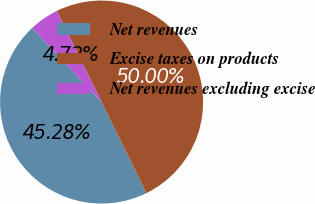<chart> <loc_0><loc_0><loc_500><loc_500><pie_chart><fcel>Net revenues<fcel>Excise taxes on products<fcel>Net revenues excluding excise<nl><fcel>45.28%<fcel>50.0%<fcel>4.72%<nl></chart> 